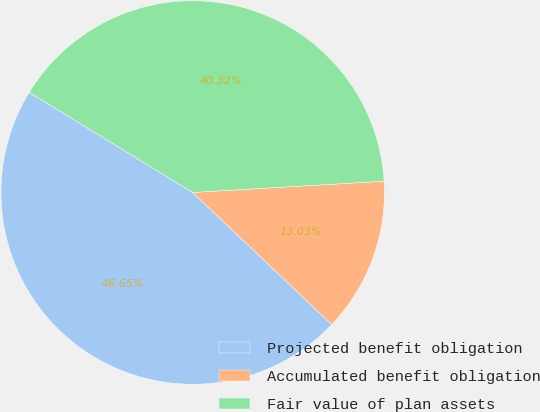Convert chart. <chart><loc_0><loc_0><loc_500><loc_500><pie_chart><fcel>Projected benefit obligation<fcel>Accumulated benefit obligation<fcel>Fair value of plan assets<nl><fcel>46.65%<fcel>13.03%<fcel>40.32%<nl></chart> 